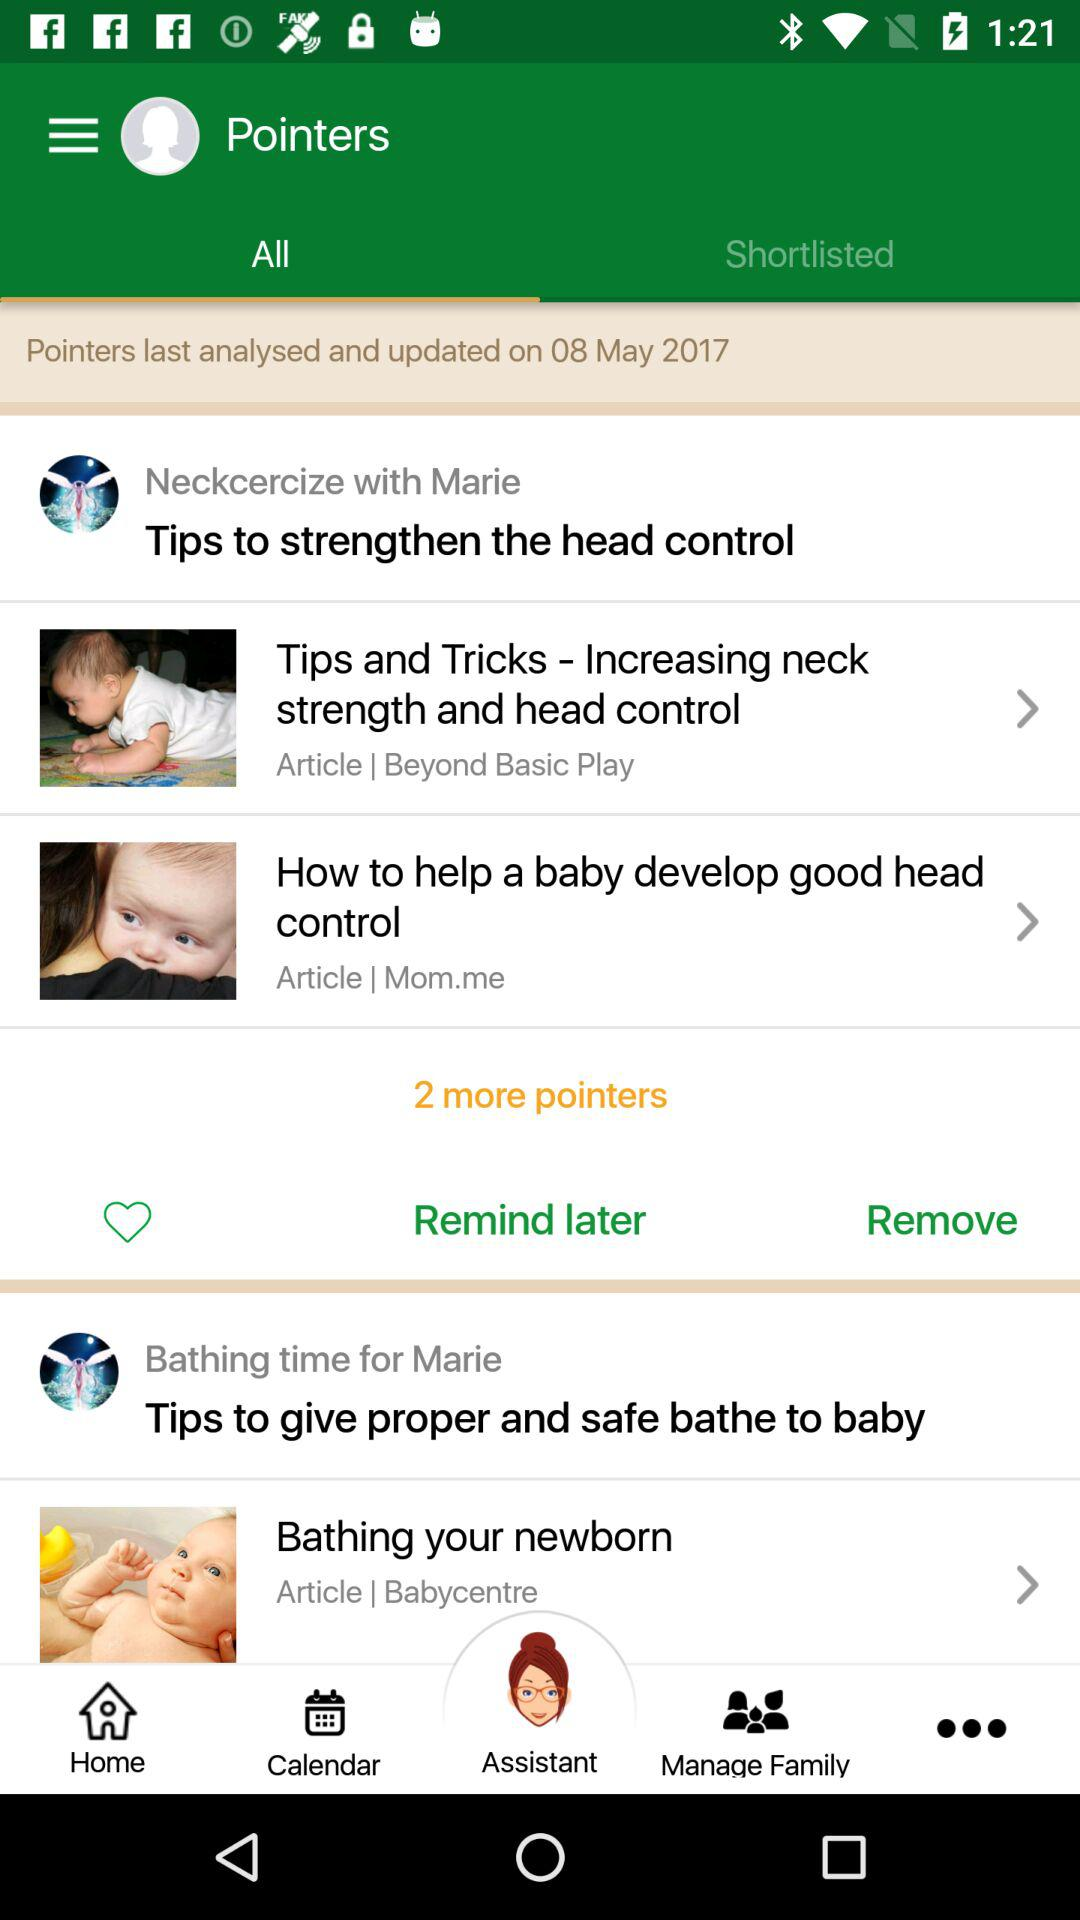How many pointers are there in total?
Answer the question using a single word or phrase. 4 